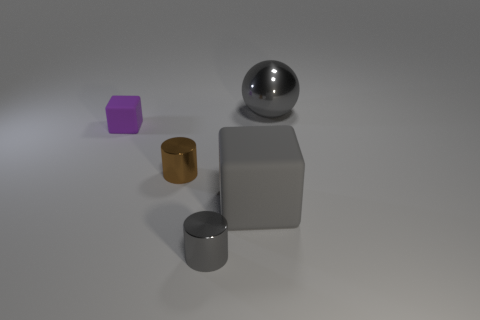Is there anything else that is the same color as the large matte thing?
Ensure brevity in your answer.  Yes. Is the gray block made of the same material as the cylinder behind the large gray rubber object?
Your response must be concise. No. There is another thing that is the same shape as the tiny brown object; what material is it?
Your answer should be compact. Metal. Is there anything else that is the same material as the small gray object?
Offer a very short reply. Yes. Are the big thing in front of the tiny brown metal thing and the gray object behind the tiny cube made of the same material?
Your answer should be compact. No. There is a cylinder that is behind the large object that is left of the large object right of the gray rubber cube; what is its color?
Offer a terse response. Brown. How many other objects are there of the same shape as the brown shiny thing?
Provide a succinct answer. 1. Does the tiny cube have the same color as the big shiny object?
Provide a succinct answer. No. What number of things are purple spheres or large objects in front of the big shiny ball?
Offer a very short reply. 1. Is there a green cylinder of the same size as the gray metallic cylinder?
Give a very brief answer. No. 